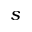Convert formula to latex. <formula><loc_0><loc_0><loc_500><loc_500>s</formula> 